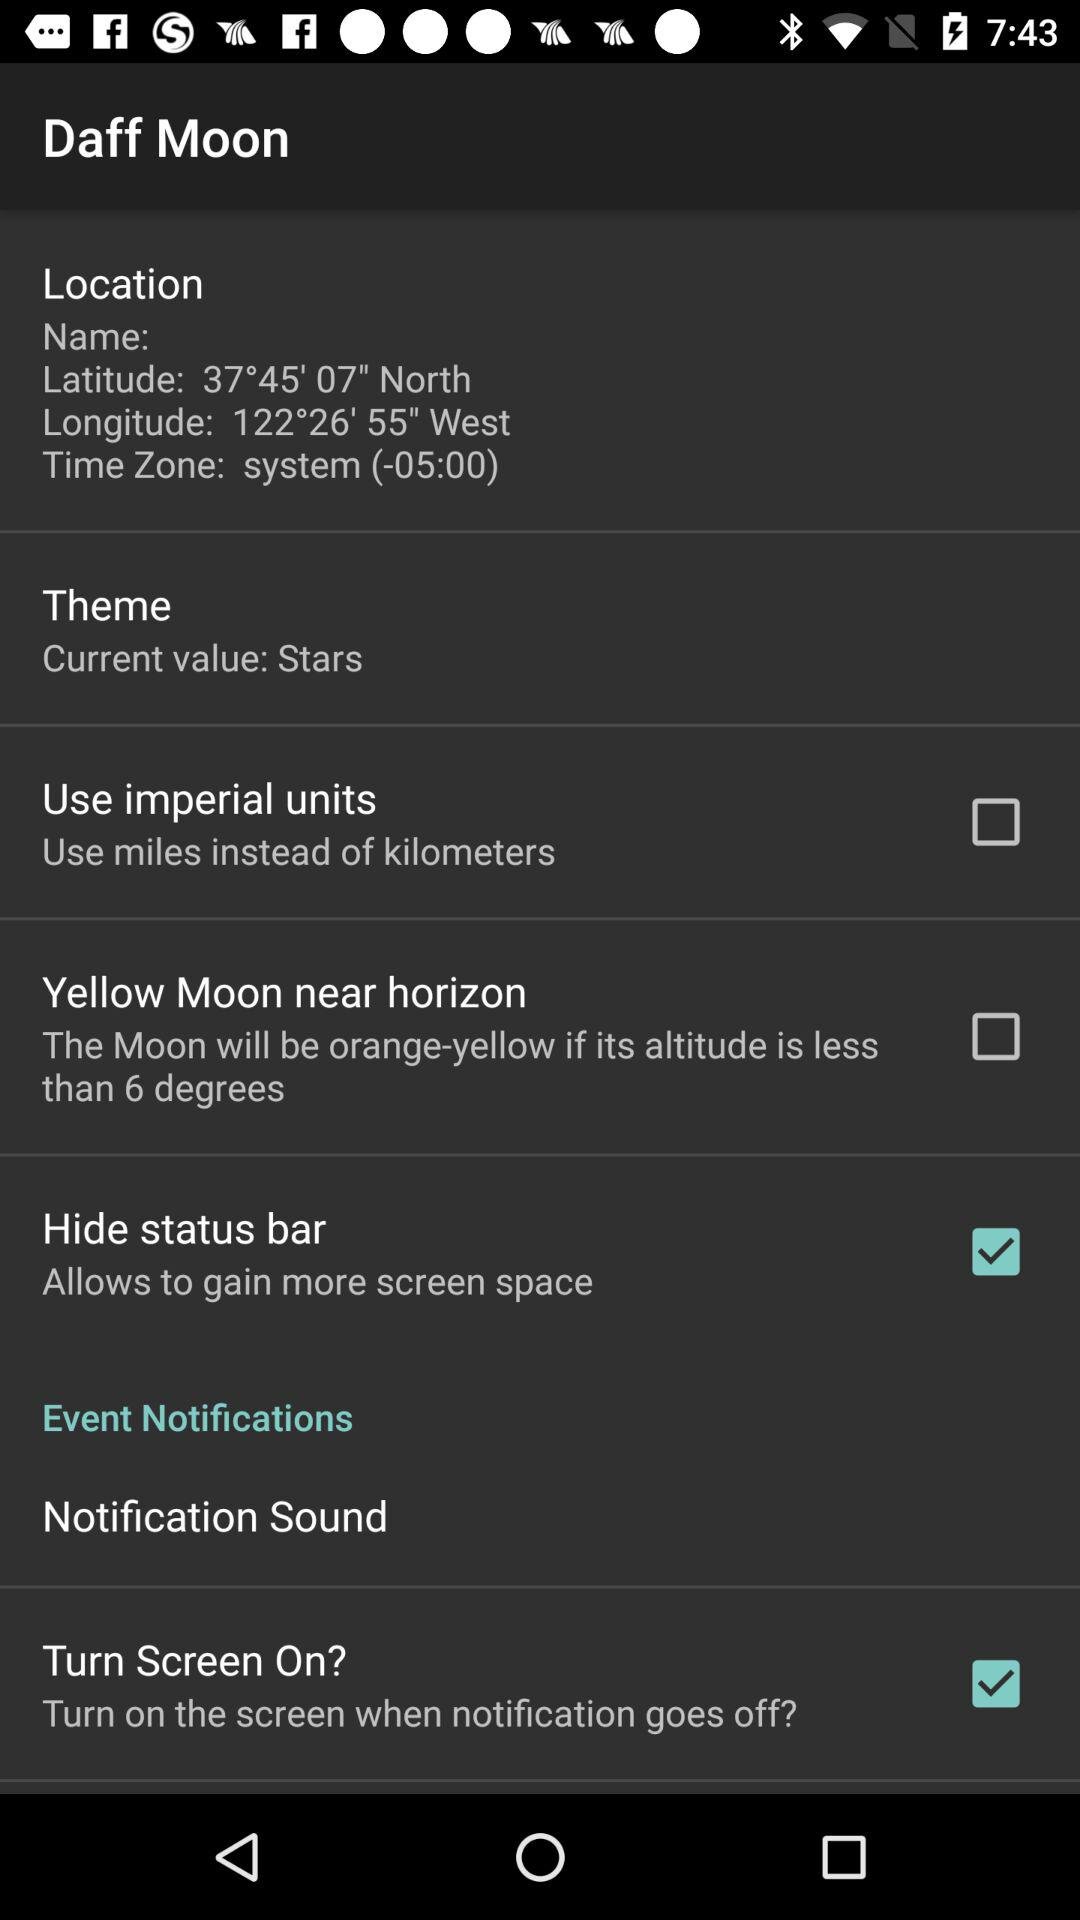What is the status of "Hide status bar"? The status is "on". 